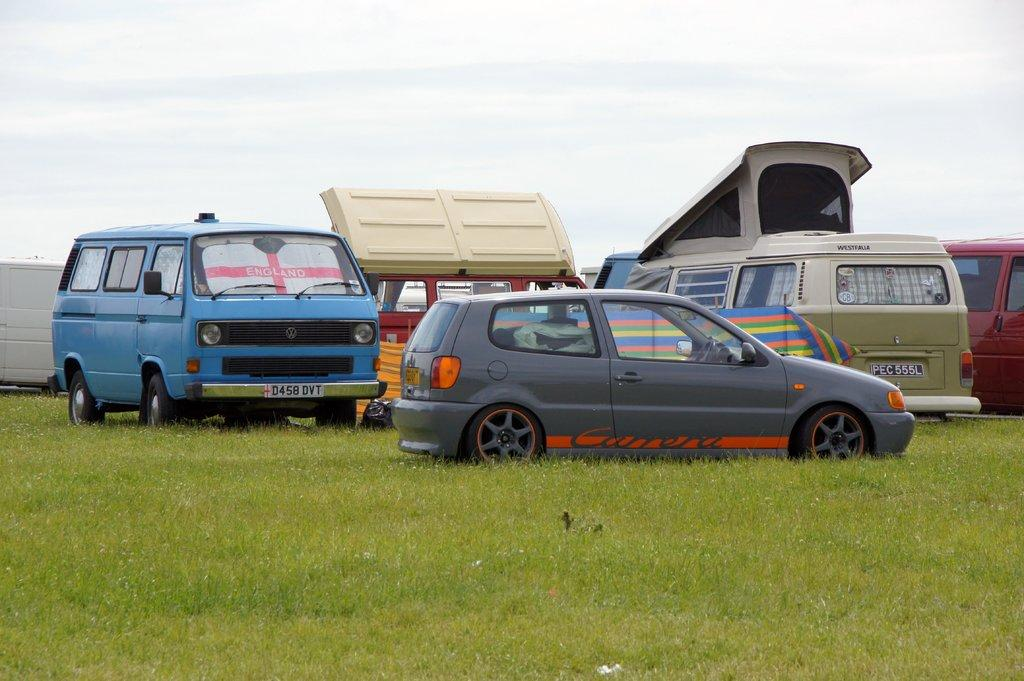What type of vehicles are on the grass in the image? The facts do not specify the type of vehicles on the grass. Can you describe the sky in the background of the image? There are clouds visible in the sky in the background of the image. What color is the hair of the family in the image? There is no mention of a family or hair in the image. 